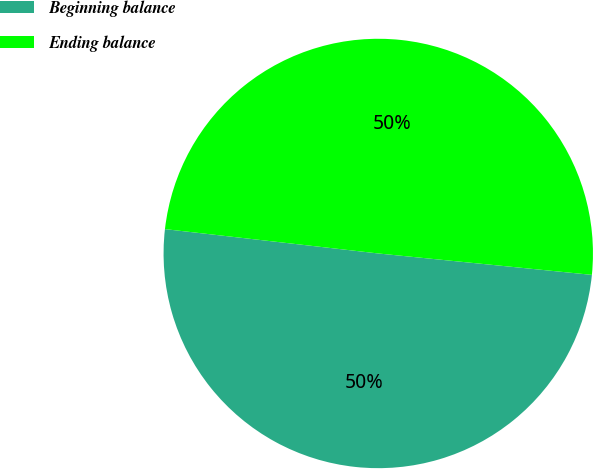Convert chart. <chart><loc_0><loc_0><loc_500><loc_500><pie_chart><fcel>Beginning balance<fcel>Ending balance<nl><fcel>50.22%<fcel>49.78%<nl></chart> 